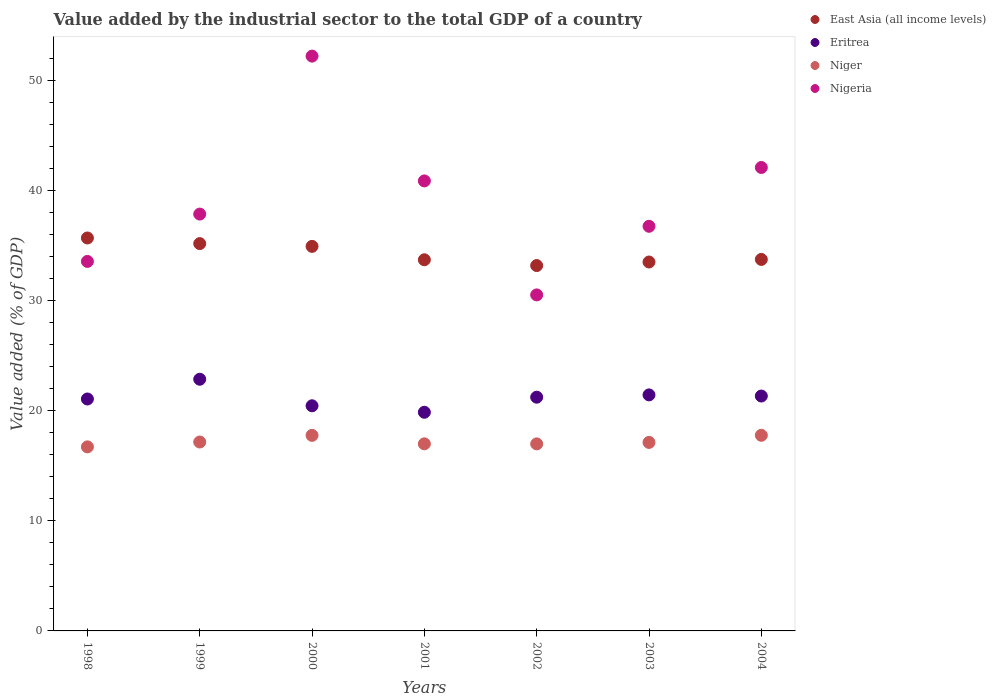How many different coloured dotlines are there?
Offer a terse response. 4. Is the number of dotlines equal to the number of legend labels?
Offer a terse response. Yes. What is the value added by the industrial sector to the total GDP in Niger in 1999?
Your answer should be very brief. 17.16. Across all years, what is the maximum value added by the industrial sector to the total GDP in Nigeria?
Keep it short and to the point. 52.21. Across all years, what is the minimum value added by the industrial sector to the total GDP in Nigeria?
Provide a succinct answer. 30.52. In which year was the value added by the industrial sector to the total GDP in Eritrea minimum?
Provide a short and direct response. 2001. What is the total value added by the industrial sector to the total GDP in East Asia (all income levels) in the graph?
Your answer should be compact. 239.93. What is the difference between the value added by the industrial sector to the total GDP in Eritrea in 1999 and that in 2000?
Offer a very short reply. 2.41. What is the difference between the value added by the industrial sector to the total GDP in East Asia (all income levels) in 1999 and the value added by the industrial sector to the total GDP in Eritrea in 2001?
Your response must be concise. 15.32. What is the average value added by the industrial sector to the total GDP in Eritrea per year?
Ensure brevity in your answer.  21.18. In the year 2003, what is the difference between the value added by the industrial sector to the total GDP in Eritrea and value added by the industrial sector to the total GDP in Nigeria?
Your answer should be very brief. -15.31. What is the ratio of the value added by the industrial sector to the total GDP in Nigeria in 2000 to that in 2001?
Keep it short and to the point. 1.28. Is the difference between the value added by the industrial sector to the total GDP in Eritrea in 1999 and 2000 greater than the difference between the value added by the industrial sector to the total GDP in Nigeria in 1999 and 2000?
Offer a terse response. Yes. What is the difference between the highest and the second highest value added by the industrial sector to the total GDP in East Asia (all income levels)?
Keep it short and to the point. 0.51. What is the difference between the highest and the lowest value added by the industrial sector to the total GDP in Eritrea?
Provide a succinct answer. 3. In how many years, is the value added by the industrial sector to the total GDP in Nigeria greater than the average value added by the industrial sector to the total GDP in Nigeria taken over all years?
Give a very brief answer. 3. Is the value added by the industrial sector to the total GDP in East Asia (all income levels) strictly greater than the value added by the industrial sector to the total GDP in Niger over the years?
Make the answer very short. Yes. How many years are there in the graph?
Offer a very short reply. 7. Are the values on the major ticks of Y-axis written in scientific E-notation?
Provide a short and direct response. No. Where does the legend appear in the graph?
Provide a succinct answer. Top right. What is the title of the graph?
Provide a short and direct response. Value added by the industrial sector to the total GDP of a country. What is the label or title of the Y-axis?
Give a very brief answer. Value added (% of GDP). What is the Value added (% of GDP) in East Asia (all income levels) in 1998?
Your response must be concise. 35.69. What is the Value added (% of GDP) in Eritrea in 1998?
Offer a terse response. 21.06. What is the Value added (% of GDP) in Niger in 1998?
Keep it short and to the point. 16.72. What is the Value added (% of GDP) of Nigeria in 1998?
Give a very brief answer. 33.56. What is the Value added (% of GDP) of East Asia (all income levels) in 1999?
Your response must be concise. 35.18. What is the Value added (% of GDP) of Eritrea in 1999?
Offer a very short reply. 22.86. What is the Value added (% of GDP) of Niger in 1999?
Provide a succinct answer. 17.16. What is the Value added (% of GDP) in Nigeria in 1999?
Give a very brief answer. 37.86. What is the Value added (% of GDP) of East Asia (all income levels) in 2000?
Offer a terse response. 34.93. What is the Value added (% of GDP) in Eritrea in 2000?
Your response must be concise. 20.45. What is the Value added (% of GDP) in Niger in 2000?
Ensure brevity in your answer.  17.76. What is the Value added (% of GDP) of Nigeria in 2000?
Make the answer very short. 52.21. What is the Value added (% of GDP) of East Asia (all income levels) in 2001?
Provide a short and direct response. 33.71. What is the Value added (% of GDP) of Eritrea in 2001?
Provide a succinct answer. 19.86. What is the Value added (% of GDP) of Niger in 2001?
Provide a short and direct response. 16.99. What is the Value added (% of GDP) in Nigeria in 2001?
Provide a short and direct response. 40.87. What is the Value added (% of GDP) of East Asia (all income levels) in 2002?
Offer a very short reply. 33.18. What is the Value added (% of GDP) of Eritrea in 2002?
Provide a short and direct response. 21.23. What is the Value added (% of GDP) of Niger in 2002?
Make the answer very short. 16.99. What is the Value added (% of GDP) of Nigeria in 2002?
Offer a terse response. 30.52. What is the Value added (% of GDP) of East Asia (all income levels) in 2003?
Offer a very short reply. 33.51. What is the Value added (% of GDP) in Eritrea in 2003?
Offer a terse response. 21.44. What is the Value added (% of GDP) in Niger in 2003?
Provide a succinct answer. 17.12. What is the Value added (% of GDP) in Nigeria in 2003?
Your answer should be compact. 36.75. What is the Value added (% of GDP) of East Asia (all income levels) in 2004?
Your answer should be very brief. 33.74. What is the Value added (% of GDP) of Eritrea in 2004?
Keep it short and to the point. 21.33. What is the Value added (% of GDP) of Niger in 2004?
Your answer should be very brief. 17.77. What is the Value added (% of GDP) of Nigeria in 2004?
Keep it short and to the point. 42.09. Across all years, what is the maximum Value added (% of GDP) in East Asia (all income levels)?
Provide a short and direct response. 35.69. Across all years, what is the maximum Value added (% of GDP) in Eritrea?
Make the answer very short. 22.86. Across all years, what is the maximum Value added (% of GDP) in Niger?
Provide a succinct answer. 17.77. Across all years, what is the maximum Value added (% of GDP) in Nigeria?
Give a very brief answer. 52.21. Across all years, what is the minimum Value added (% of GDP) in East Asia (all income levels)?
Give a very brief answer. 33.18. Across all years, what is the minimum Value added (% of GDP) of Eritrea?
Offer a very short reply. 19.86. Across all years, what is the minimum Value added (% of GDP) in Niger?
Offer a terse response. 16.72. Across all years, what is the minimum Value added (% of GDP) in Nigeria?
Give a very brief answer. 30.52. What is the total Value added (% of GDP) of East Asia (all income levels) in the graph?
Offer a very short reply. 239.93. What is the total Value added (% of GDP) in Eritrea in the graph?
Provide a short and direct response. 148.23. What is the total Value added (% of GDP) in Niger in the graph?
Your answer should be compact. 120.5. What is the total Value added (% of GDP) in Nigeria in the graph?
Your answer should be very brief. 273.85. What is the difference between the Value added (% of GDP) of East Asia (all income levels) in 1998 and that in 1999?
Make the answer very short. 0.51. What is the difference between the Value added (% of GDP) of Eritrea in 1998 and that in 1999?
Provide a short and direct response. -1.79. What is the difference between the Value added (% of GDP) in Niger in 1998 and that in 1999?
Keep it short and to the point. -0.44. What is the difference between the Value added (% of GDP) of Nigeria in 1998 and that in 1999?
Your answer should be very brief. -4.3. What is the difference between the Value added (% of GDP) of East Asia (all income levels) in 1998 and that in 2000?
Offer a terse response. 0.76. What is the difference between the Value added (% of GDP) of Eritrea in 1998 and that in 2000?
Ensure brevity in your answer.  0.62. What is the difference between the Value added (% of GDP) in Niger in 1998 and that in 2000?
Offer a very short reply. -1.04. What is the difference between the Value added (% of GDP) in Nigeria in 1998 and that in 2000?
Ensure brevity in your answer.  -18.65. What is the difference between the Value added (% of GDP) of East Asia (all income levels) in 1998 and that in 2001?
Your answer should be compact. 1.98. What is the difference between the Value added (% of GDP) of Eritrea in 1998 and that in 2001?
Give a very brief answer. 1.2. What is the difference between the Value added (% of GDP) in Niger in 1998 and that in 2001?
Provide a succinct answer. -0.28. What is the difference between the Value added (% of GDP) of Nigeria in 1998 and that in 2001?
Your response must be concise. -7.31. What is the difference between the Value added (% of GDP) of East Asia (all income levels) in 1998 and that in 2002?
Keep it short and to the point. 2.51. What is the difference between the Value added (% of GDP) of Eritrea in 1998 and that in 2002?
Provide a short and direct response. -0.16. What is the difference between the Value added (% of GDP) of Niger in 1998 and that in 2002?
Your response must be concise. -0.27. What is the difference between the Value added (% of GDP) in Nigeria in 1998 and that in 2002?
Offer a very short reply. 3.04. What is the difference between the Value added (% of GDP) in East Asia (all income levels) in 1998 and that in 2003?
Ensure brevity in your answer.  2.18. What is the difference between the Value added (% of GDP) of Eritrea in 1998 and that in 2003?
Your answer should be very brief. -0.37. What is the difference between the Value added (% of GDP) of Niger in 1998 and that in 2003?
Keep it short and to the point. -0.41. What is the difference between the Value added (% of GDP) of Nigeria in 1998 and that in 2003?
Keep it short and to the point. -3.19. What is the difference between the Value added (% of GDP) of East Asia (all income levels) in 1998 and that in 2004?
Your answer should be very brief. 1.95. What is the difference between the Value added (% of GDP) of Eritrea in 1998 and that in 2004?
Your response must be concise. -0.27. What is the difference between the Value added (% of GDP) of Niger in 1998 and that in 2004?
Offer a very short reply. -1.05. What is the difference between the Value added (% of GDP) in Nigeria in 1998 and that in 2004?
Your answer should be very brief. -8.53. What is the difference between the Value added (% of GDP) in East Asia (all income levels) in 1999 and that in 2000?
Provide a short and direct response. 0.25. What is the difference between the Value added (% of GDP) of Eritrea in 1999 and that in 2000?
Give a very brief answer. 2.41. What is the difference between the Value added (% of GDP) of Niger in 1999 and that in 2000?
Your answer should be compact. -0.6. What is the difference between the Value added (% of GDP) of Nigeria in 1999 and that in 2000?
Offer a terse response. -14.35. What is the difference between the Value added (% of GDP) in East Asia (all income levels) in 1999 and that in 2001?
Provide a short and direct response. 1.47. What is the difference between the Value added (% of GDP) of Eritrea in 1999 and that in 2001?
Your answer should be compact. 3. What is the difference between the Value added (% of GDP) in Niger in 1999 and that in 2001?
Ensure brevity in your answer.  0.17. What is the difference between the Value added (% of GDP) in Nigeria in 1999 and that in 2001?
Your response must be concise. -3.01. What is the difference between the Value added (% of GDP) in East Asia (all income levels) in 1999 and that in 2002?
Keep it short and to the point. 1.99. What is the difference between the Value added (% of GDP) of Eritrea in 1999 and that in 2002?
Make the answer very short. 1.63. What is the difference between the Value added (% of GDP) in Niger in 1999 and that in 2002?
Make the answer very short. 0.17. What is the difference between the Value added (% of GDP) of Nigeria in 1999 and that in 2002?
Offer a terse response. 7.34. What is the difference between the Value added (% of GDP) of East Asia (all income levels) in 1999 and that in 2003?
Ensure brevity in your answer.  1.67. What is the difference between the Value added (% of GDP) in Eritrea in 1999 and that in 2003?
Your response must be concise. 1.42. What is the difference between the Value added (% of GDP) of Niger in 1999 and that in 2003?
Offer a very short reply. 0.04. What is the difference between the Value added (% of GDP) in Nigeria in 1999 and that in 2003?
Provide a short and direct response. 1.11. What is the difference between the Value added (% of GDP) in East Asia (all income levels) in 1999 and that in 2004?
Ensure brevity in your answer.  1.44. What is the difference between the Value added (% of GDP) in Eritrea in 1999 and that in 2004?
Offer a very short reply. 1.53. What is the difference between the Value added (% of GDP) in Niger in 1999 and that in 2004?
Provide a succinct answer. -0.61. What is the difference between the Value added (% of GDP) of Nigeria in 1999 and that in 2004?
Offer a very short reply. -4.23. What is the difference between the Value added (% of GDP) in East Asia (all income levels) in 2000 and that in 2001?
Your answer should be compact. 1.22. What is the difference between the Value added (% of GDP) of Eritrea in 2000 and that in 2001?
Your answer should be very brief. 0.59. What is the difference between the Value added (% of GDP) in Niger in 2000 and that in 2001?
Your answer should be compact. 0.77. What is the difference between the Value added (% of GDP) of Nigeria in 2000 and that in 2001?
Your response must be concise. 11.33. What is the difference between the Value added (% of GDP) in East Asia (all income levels) in 2000 and that in 2002?
Offer a very short reply. 1.74. What is the difference between the Value added (% of GDP) of Eritrea in 2000 and that in 2002?
Your response must be concise. -0.78. What is the difference between the Value added (% of GDP) of Niger in 2000 and that in 2002?
Make the answer very short. 0.77. What is the difference between the Value added (% of GDP) of Nigeria in 2000 and that in 2002?
Ensure brevity in your answer.  21.69. What is the difference between the Value added (% of GDP) of East Asia (all income levels) in 2000 and that in 2003?
Provide a short and direct response. 1.42. What is the difference between the Value added (% of GDP) of Eritrea in 2000 and that in 2003?
Provide a short and direct response. -0.99. What is the difference between the Value added (% of GDP) in Niger in 2000 and that in 2003?
Provide a succinct answer. 0.64. What is the difference between the Value added (% of GDP) of Nigeria in 2000 and that in 2003?
Your answer should be very brief. 15.46. What is the difference between the Value added (% of GDP) in East Asia (all income levels) in 2000 and that in 2004?
Offer a very short reply. 1.19. What is the difference between the Value added (% of GDP) of Eritrea in 2000 and that in 2004?
Keep it short and to the point. -0.89. What is the difference between the Value added (% of GDP) in Niger in 2000 and that in 2004?
Provide a succinct answer. -0.01. What is the difference between the Value added (% of GDP) in Nigeria in 2000 and that in 2004?
Offer a very short reply. 10.11. What is the difference between the Value added (% of GDP) in East Asia (all income levels) in 2001 and that in 2002?
Provide a succinct answer. 0.53. What is the difference between the Value added (% of GDP) of Eritrea in 2001 and that in 2002?
Your answer should be compact. -1.37. What is the difference between the Value added (% of GDP) in Niger in 2001 and that in 2002?
Your answer should be very brief. 0. What is the difference between the Value added (% of GDP) of Nigeria in 2001 and that in 2002?
Provide a succinct answer. 10.35. What is the difference between the Value added (% of GDP) of East Asia (all income levels) in 2001 and that in 2003?
Ensure brevity in your answer.  0.2. What is the difference between the Value added (% of GDP) in Eritrea in 2001 and that in 2003?
Give a very brief answer. -1.58. What is the difference between the Value added (% of GDP) in Niger in 2001 and that in 2003?
Provide a short and direct response. -0.13. What is the difference between the Value added (% of GDP) of Nigeria in 2001 and that in 2003?
Provide a short and direct response. 4.12. What is the difference between the Value added (% of GDP) in East Asia (all income levels) in 2001 and that in 2004?
Provide a short and direct response. -0.03. What is the difference between the Value added (% of GDP) of Eritrea in 2001 and that in 2004?
Your answer should be very brief. -1.47. What is the difference between the Value added (% of GDP) of Niger in 2001 and that in 2004?
Your response must be concise. -0.77. What is the difference between the Value added (% of GDP) in Nigeria in 2001 and that in 2004?
Ensure brevity in your answer.  -1.22. What is the difference between the Value added (% of GDP) of East Asia (all income levels) in 2002 and that in 2003?
Your response must be concise. -0.32. What is the difference between the Value added (% of GDP) of Eritrea in 2002 and that in 2003?
Your answer should be compact. -0.21. What is the difference between the Value added (% of GDP) of Niger in 2002 and that in 2003?
Your answer should be very brief. -0.13. What is the difference between the Value added (% of GDP) of Nigeria in 2002 and that in 2003?
Give a very brief answer. -6.23. What is the difference between the Value added (% of GDP) of East Asia (all income levels) in 2002 and that in 2004?
Ensure brevity in your answer.  -0.56. What is the difference between the Value added (% of GDP) in Eritrea in 2002 and that in 2004?
Offer a terse response. -0.1. What is the difference between the Value added (% of GDP) of Niger in 2002 and that in 2004?
Give a very brief answer. -0.78. What is the difference between the Value added (% of GDP) of Nigeria in 2002 and that in 2004?
Ensure brevity in your answer.  -11.57. What is the difference between the Value added (% of GDP) in East Asia (all income levels) in 2003 and that in 2004?
Provide a succinct answer. -0.23. What is the difference between the Value added (% of GDP) of Eritrea in 2003 and that in 2004?
Your answer should be very brief. 0.1. What is the difference between the Value added (% of GDP) of Niger in 2003 and that in 2004?
Your answer should be compact. -0.64. What is the difference between the Value added (% of GDP) in Nigeria in 2003 and that in 2004?
Your answer should be very brief. -5.34. What is the difference between the Value added (% of GDP) in East Asia (all income levels) in 1998 and the Value added (% of GDP) in Eritrea in 1999?
Offer a very short reply. 12.83. What is the difference between the Value added (% of GDP) in East Asia (all income levels) in 1998 and the Value added (% of GDP) in Niger in 1999?
Provide a short and direct response. 18.53. What is the difference between the Value added (% of GDP) in East Asia (all income levels) in 1998 and the Value added (% of GDP) in Nigeria in 1999?
Your answer should be very brief. -2.17. What is the difference between the Value added (% of GDP) in Eritrea in 1998 and the Value added (% of GDP) in Niger in 1999?
Make the answer very short. 3.91. What is the difference between the Value added (% of GDP) of Eritrea in 1998 and the Value added (% of GDP) of Nigeria in 1999?
Your answer should be compact. -16.79. What is the difference between the Value added (% of GDP) of Niger in 1998 and the Value added (% of GDP) of Nigeria in 1999?
Your answer should be very brief. -21.14. What is the difference between the Value added (% of GDP) in East Asia (all income levels) in 1998 and the Value added (% of GDP) in Eritrea in 2000?
Offer a very short reply. 15.24. What is the difference between the Value added (% of GDP) of East Asia (all income levels) in 1998 and the Value added (% of GDP) of Niger in 2000?
Give a very brief answer. 17.93. What is the difference between the Value added (% of GDP) of East Asia (all income levels) in 1998 and the Value added (% of GDP) of Nigeria in 2000?
Ensure brevity in your answer.  -16.52. What is the difference between the Value added (% of GDP) in Eritrea in 1998 and the Value added (% of GDP) in Niger in 2000?
Offer a very short reply. 3.3. What is the difference between the Value added (% of GDP) in Eritrea in 1998 and the Value added (% of GDP) in Nigeria in 2000?
Your response must be concise. -31.14. What is the difference between the Value added (% of GDP) of Niger in 1998 and the Value added (% of GDP) of Nigeria in 2000?
Keep it short and to the point. -35.49. What is the difference between the Value added (% of GDP) of East Asia (all income levels) in 1998 and the Value added (% of GDP) of Eritrea in 2001?
Offer a very short reply. 15.83. What is the difference between the Value added (% of GDP) of East Asia (all income levels) in 1998 and the Value added (% of GDP) of Niger in 2001?
Offer a terse response. 18.7. What is the difference between the Value added (% of GDP) of East Asia (all income levels) in 1998 and the Value added (% of GDP) of Nigeria in 2001?
Offer a very short reply. -5.18. What is the difference between the Value added (% of GDP) of Eritrea in 1998 and the Value added (% of GDP) of Niger in 2001?
Provide a short and direct response. 4.07. What is the difference between the Value added (% of GDP) of Eritrea in 1998 and the Value added (% of GDP) of Nigeria in 2001?
Offer a terse response. -19.81. What is the difference between the Value added (% of GDP) of Niger in 1998 and the Value added (% of GDP) of Nigeria in 2001?
Offer a terse response. -24.16. What is the difference between the Value added (% of GDP) in East Asia (all income levels) in 1998 and the Value added (% of GDP) in Eritrea in 2002?
Make the answer very short. 14.46. What is the difference between the Value added (% of GDP) in East Asia (all income levels) in 1998 and the Value added (% of GDP) in Niger in 2002?
Your response must be concise. 18.7. What is the difference between the Value added (% of GDP) of East Asia (all income levels) in 1998 and the Value added (% of GDP) of Nigeria in 2002?
Offer a very short reply. 5.17. What is the difference between the Value added (% of GDP) of Eritrea in 1998 and the Value added (% of GDP) of Niger in 2002?
Ensure brevity in your answer.  4.08. What is the difference between the Value added (% of GDP) of Eritrea in 1998 and the Value added (% of GDP) of Nigeria in 2002?
Your response must be concise. -9.45. What is the difference between the Value added (% of GDP) in Niger in 1998 and the Value added (% of GDP) in Nigeria in 2002?
Give a very brief answer. -13.8. What is the difference between the Value added (% of GDP) in East Asia (all income levels) in 1998 and the Value added (% of GDP) in Eritrea in 2003?
Your answer should be very brief. 14.25. What is the difference between the Value added (% of GDP) in East Asia (all income levels) in 1998 and the Value added (% of GDP) in Niger in 2003?
Your answer should be compact. 18.57. What is the difference between the Value added (% of GDP) of East Asia (all income levels) in 1998 and the Value added (% of GDP) of Nigeria in 2003?
Provide a succinct answer. -1.06. What is the difference between the Value added (% of GDP) in Eritrea in 1998 and the Value added (% of GDP) in Niger in 2003?
Ensure brevity in your answer.  3.94. What is the difference between the Value added (% of GDP) of Eritrea in 1998 and the Value added (% of GDP) of Nigeria in 2003?
Keep it short and to the point. -15.69. What is the difference between the Value added (% of GDP) of Niger in 1998 and the Value added (% of GDP) of Nigeria in 2003?
Keep it short and to the point. -20.03. What is the difference between the Value added (% of GDP) in East Asia (all income levels) in 1998 and the Value added (% of GDP) in Eritrea in 2004?
Offer a terse response. 14.36. What is the difference between the Value added (% of GDP) in East Asia (all income levels) in 1998 and the Value added (% of GDP) in Niger in 2004?
Provide a short and direct response. 17.92. What is the difference between the Value added (% of GDP) of East Asia (all income levels) in 1998 and the Value added (% of GDP) of Nigeria in 2004?
Offer a terse response. -6.4. What is the difference between the Value added (% of GDP) of Eritrea in 1998 and the Value added (% of GDP) of Niger in 2004?
Make the answer very short. 3.3. What is the difference between the Value added (% of GDP) of Eritrea in 1998 and the Value added (% of GDP) of Nigeria in 2004?
Give a very brief answer. -21.03. What is the difference between the Value added (% of GDP) in Niger in 1998 and the Value added (% of GDP) in Nigeria in 2004?
Provide a short and direct response. -25.37. What is the difference between the Value added (% of GDP) of East Asia (all income levels) in 1999 and the Value added (% of GDP) of Eritrea in 2000?
Keep it short and to the point. 14.73. What is the difference between the Value added (% of GDP) in East Asia (all income levels) in 1999 and the Value added (% of GDP) in Niger in 2000?
Provide a short and direct response. 17.42. What is the difference between the Value added (% of GDP) in East Asia (all income levels) in 1999 and the Value added (% of GDP) in Nigeria in 2000?
Your answer should be compact. -17.03. What is the difference between the Value added (% of GDP) of Eritrea in 1999 and the Value added (% of GDP) of Niger in 2000?
Your response must be concise. 5.1. What is the difference between the Value added (% of GDP) in Eritrea in 1999 and the Value added (% of GDP) in Nigeria in 2000?
Provide a short and direct response. -29.35. What is the difference between the Value added (% of GDP) of Niger in 1999 and the Value added (% of GDP) of Nigeria in 2000?
Offer a terse response. -35.05. What is the difference between the Value added (% of GDP) in East Asia (all income levels) in 1999 and the Value added (% of GDP) in Eritrea in 2001?
Provide a short and direct response. 15.32. What is the difference between the Value added (% of GDP) in East Asia (all income levels) in 1999 and the Value added (% of GDP) in Niger in 2001?
Your answer should be very brief. 18.19. What is the difference between the Value added (% of GDP) in East Asia (all income levels) in 1999 and the Value added (% of GDP) in Nigeria in 2001?
Provide a succinct answer. -5.69. What is the difference between the Value added (% of GDP) of Eritrea in 1999 and the Value added (% of GDP) of Niger in 2001?
Offer a terse response. 5.87. What is the difference between the Value added (% of GDP) in Eritrea in 1999 and the Value added (% of GDP) in Nigeria in 2001?
Give a very brief answer. -18.01. What is the difference between the Value added (% of GDP) in Niger in 1999 and the Value added (% of GDP) in Nigeria in 2001?
Make the answer very short. -23.71. What is the difference between the Value added (% of GDP) in East Asia (all income levels) in 1999 and the Value added (% of GDP) in Eritrea in 2002?
Keep it short and to the point. 13.95. What is the difference between the Value added (% of GDP) in East Asia (all income levels) in 1999 and the Value added (% of GDP) in Niger in 2002?
Keep it short and to the point. 18.19. What is the difference between the Value added (% of GDP) of East Asia (all income levels) in 1999 and the Value added (% of GDP) of Nigeria in 2002?
Your answer should be compact. 4.66. What is the difference between the Value added (% of GDP) in Eritrea in 1999 and the Value added (% of GDP) in Niger in 2002?
Offer a terse response. 5.87. What is the difference between the Value added (% of GDP) in Eritrea in 1999 and the Value added (% of GDP) in Nigeria in 2002?
Your answer should be compact. -7.66. What is the difference between the Value added (% of GDP) in Niger in 1999 and the Value added (% of GDP) in Nigeria in 2002?
Offer a terse response. -13.36. What is the difference between the Value added (% of GDP) in East Asia (all income levels) in 1999 and the Value added (% of GDP) in Eritrea in 2003?
Offer a terse response. 13.74. What is the difference between the Value added (% of GDP) of East Asia (all income levels) in 1999 and the Value added (% of GDP) of Niger in 2003?
Keep it short and to the point. 18.06. What is the difference between the Value added (% of GDP) in East Asia (all income levels) in 1999 and the Value added (% of GDP) in Nigeria in 2003?
Your answer should be compact. -1.57. What is the difference between the Value added (% of GDP) of Eritrea in 1999 and the Value added (% of GDP) of Niger in 2003?
Your response must be concise. 5.74. What is the difference between the Value added (% of GDP) in Eritrea in 1999 and the Value added (% of GDP) in Nigeria in 2003?
Provide a short and direct response. -13.89. What is the difference between the Value added (% of GDP) of Niger in 1999 and the Value added (% of GDP) of Nigeria in 2003?
Keep it short and to the point. -19.59. What is the difference between the Value added (% of GDP) in East Asia (all income levels) in 1999 and the Value added (% of GDP) in Eritrea in 2004?
Provide a short and direct response. 13.84. What is the difference between the Value added (% of GDP) in East Asia (all income levels) in 1999 and the Value added (% of GDP) in Niger in 2004?
Offer a very short reply. 17.41. What is the difference between the Value added (% of GDP) of East Asia (all income levels) in 1999 and the Value added (% of GDP) of Nigeria in 2004?
Ensure brevity in your answer.  -6.91. What is the difference between the Value added (% of GDP) of Eritrea in 1999 and the Value added (% of GDP) of Niger in 2004?
Your response must be concise. 5.09. What is the difference between the Value added (% of GDP) of Eritrea in 1999 and the Value added (% of GDP) of Nigeria in 2004?
Offer a terse response. -19.23. What is the difference between the Value added (% of GDP) of Niger in 1999 and the Value added (% of GDP) of Nigeria in 2004?
Keep it short and to the point. -24.93. What is the difference between the Value added (% of GDP) in East Asia (all income levels) in 2000 and the Value added (% of GDP) in Eritrea in 2001?
Your answer should be compact. 15.07. What is the difference between the Value added (% of GDP) in East Asia (all income levels) in 2000 and the Value added (% of GDP) in Niger in 2001?
Keep it short and to the point. 17.93. What is the difference between the Value added (% of GDP) of East Asia (all income levels) in 2000 and the Value added (% of GDP) of Nigeria in 2001?
Your answer should be very brief. -5.95. What is the difference between the Value added (% of GDP) in Eritrea in 2000 and the Value added (% of GDP) in Niger in 2001?
Your response must be concise. 3.46. What is the difference between the Value added (% of GDP) of Eritrea in 2000 and the Value added (% of GDP) of Nigeria in 2001?
Offer a very short reply. -20.42. What is the difference between the Value added (% of GDP) in Niger in 2000 and the Value added (% of GDP) in Nigeria in 2001?
Your answer should be compact. -23.11. What is the difference between the Value added (% of GDP) of East Asia (all income levels) in 2000 and the Value added (% of GDP) of Eritrea in 2002?
Your answer should be compact. 13.7. What is the difference between the Value added (% of GDP) of East Asia (all income levels) in 2000 and the Value added (% of GDP) of Niger in 2002?
Your answer should be compact. 17.94. What is the difference between the Value added (% of GDP) of East Asia (all income levels) in 2000 and the Value added (% of GDP) of Nigeria in 2002?
Your answer should be compact. 4.41. What is the difference between the Value added (% of GDP) in Eritrea in 2000 and the Value added (% of GDP) in Niger in 2002?
Make the answer very short. 3.46. What is the difference between the Value added (% of GDP) in Eritrea in 2000 and the Value added (% of GDP) in Nigeria in 2002?
Offer a very short reply. -10.07. What is the difference between the Value added (% of GDP) of Niger in 2000 and the Value added (% of GDP) of Nigeria in 2002?
Offer a terse response. -12.76. What is the difference between the Value added (% of GDP) of East Asia (all income levels) in 2000 and the Value added (% of GDP) of Eritrea in 2003?
Give a very brief answer. 13.49. What is the difference between the Value added (% of GDP) in East Asia (all income levels) in 2000 and the Value added (% of GDP) in Niger in 2003?
Keep it short and to the point. 17.81. What is the difference between the Value added (% of GDP) in East Asia (all income levels) in 2000 and the Value added (% of GDP) in Nigeria in 2003?
Provide a succinct answer. -1.82. What is the difference between the Value added (% of GDP) in Eritrea in 2000 and the Value added (% of GDP) in Niger in 2003?
Ensure brevity in your answer.  3.33. What is the difference between the Value added (% of GDP) in Eritrea in 2000 and the Value added (% of GDP) in Nigeria in 2003?
Ensure brevity in your answer.  -16.3. What is the difference between the Value added (% of GDP) of Niger in 2000 and the Value added (% of GDP) of Nigeria in 2003?
Your answer should be compact. -18.99. What is the difference between the Value added (% of GDP) in East Asia (all income levels) in 2000 and the Value added (% of GDP) in Eritrea in 2004?
Give a very brief answer. 13.59. What is the difference between the Value added (% of GDP) in East Asia (all income levels) in 2000 and the Value added (% of GDP) in Niger in 2004?
Offer a terse response. 17.16. What is the difference between the Value added (% of GDP) in East Asia (all income levels) in 2000 and the Value added (% of GDP) in Nigeria in 2004?
Make the answer very short. -7.16. What is the difference between the Value added (% of GDP) in Eritrea in 2000 and the Value added (% of GDP) in Niger in 2004?
Provide a succinct answer. 2.68. What is the difference between the Value added (% of GDP) of Eritrea in 2000 and the Value added (% of GDP) of Nigeria in 2004?
Offer a very short reply. -21.64. What is the difference between the Value added (% of GDP) in Niger in 2000 and the Value added (% of GDP) in Nigeria in 2004?
Your answer should be compact. -24.33. What is the difference between the Value added (% of GDP) of East Asia (all income levels) in 2001 and the Value added (% of GDP) of Eritrea in 2002?
Offer a very short reply. 12.48. What is the difference between the Value added (% of GDP) of East Asia (all income levels) in 2001 and the Value added (% of GDP) of Niger in 2002?
Give a very brief answer. 16.72. What is the difference between the Value added (% of GDP) of East Asia (all income levels) in 2001 and the Value added (% of GDP) of Nigeria in 2002?
Your response must be concise. 3.19. What is the difference between the Value added (% of GDP) of Eritrea in 2001 and the Value added (% of GDP) of Niger in 2002?
Make the answer very short. 2.87. What is the difference between the Value added (% of GDP) of Eritrea in 2001 and the Value added (% of GDP) of Nigeria in 2002?
Your answer should be very brief. -10.66. What is the difference between the Value added (% of GDP) in Niger in 2001 and the Value added (% of GDP) in Nigeria in 2002?
Your response must be concise. -13.53. What is the difference between the Value added (% of GDP) in East Asia (all income levels) in 2001 and the Value added (% of GDP) in Eritrea in 2003?
Your answer should be very brief. 12.27. What is the difference between the Value added (% of GDP) of East Asia (all income levels) in 2001 and the Value added (% of GDP) of Niger in 2003?
Make the answer very short. 16.59. What is the difference between the Value added (% of GDP) of East Asia (all income levels) in 2001 and the Value added (% of GDP) of Nigeria in 2003?
Your answer should be compact. -3.04. What is the difference between the Value added (% of GDP) in Eritrea in 2001 and the Value added (% of GDP) in Niger in 2003?
Your answer should be very brief. 2.74. What is the difference between the Value added (% of GDP) in Eritrea in 2001 and the Value added (% of GDP) in Nigeria in 2003?
Make the answer very short. -16.89. What is the difference between the Value added (% of GDP) in Niger in 2001 and the Value added (% of GDP) in Nigeria in 2003?
Make the answer very short. -19.76. What is the difference between the Value added (% of GDP) in East Asia (all income levels) in 2001 and the Value added (% of GDP) in Eritrea in 2004?
Your answer should be very brief. 12.38. What is the difference between the Value added (% of GDP) of East Asia (all income levels) in 2001 and the Value added (% of GDP) of Niger in 2004?
Your answer should be very brief. 15.94. What is the difference between the Value added (% of GDP) in East Asia (all income levels) in 2001 and the Value added (% of GDP) in Nigeria in 2004?
Give a very brief answer. -8.38. What is the difference between the Value added (% of GDP) in Eritrea in 2001 and the Value added (% of GDP) in Niger in 2004?
Provide a succinct answer. 2.09. What is the difference between the Value added (% of GDP) of Eritrea in 2001 and the Value added (% of GDP) of Nigeria in 2004?
Provide a short and direct response. -22.23. What is the difference between the Value added (% of GDP) in Niger in 2001 and the Value added (% of GDP) in Nigeria in 2004?
Your answer should be very brief. -25.1. What is the difference between the Value added (% of GDP) of East Asia (all income levels) in 2002 and the Value added (% of GDP) of Eritrea in 2003?
Keep it short and to the point. 11.75. What is the difference between the Value added (% of GDP) of East Asia (all income levels) in 2002 and the Value added (% of GDP) of Niger in 2003?
Offer a terse response. 16.06. What is the difference between the Value added (% of GDP) of East Asia (all income levels) in 2002 and the Value added (% of GDP) of Nigeria in 2003?
Provide a short and direct response. -3.57. What is the difference between the Value added (% of GDP) of Eritrea in 2002 and the Value added (% of GDP) of Niger in 2003?
Offer a very short reply. 4.11. What is the difference between the Value added (% of GDP) of Eritrea in 2002 and the Value added (% of GDP) of Nigeria in 2003?
Your response must be concise. -15.52. What is the difference between the Value added (% of GDP) in Niger in 2002 and the Value added (% of GDP) in Nigeria in 2003?
Provide a short and direct response. -19.76. What is the difference between the Value added (% of GDP) of East Asia (all income levels) in 2002 and the Value added (% of GDP) of Eritrea in 2004?
Provide a succinct answer. 11.85. What is the difference between the Value added (% of GDP) of East Asia (all income levels) in 2002 and the Value added (% of GDP) of Niger in 2004?
Give a very brief answer. 15.42. What is the difference between the Value added (% of GDP) of East Asia (all income levels) in 2002 and the Value added (% of GDP) of Nigeria in 2004?
Provide a succinct answer. -8.91. What is the difference between the Value added (% of GDP) in Eritrea in 2002 and the Value added (% of GDP) in Niger in 2004?
Make the answer very short. 3.46. What is the difference between the Value added (% of GDP) in Eritrea in 2002 and the Value added (% of GDP) in Nigeria in 2004?
Your answer should be compact. -20.86. What is the difference between the Value added (% of GDP) of Niger in 2002 and the Value added (% of GDP) of Nigeria in 2004?
Offer a very short reply. -25.1. What is the difference between the Value added (% of GDP) of East Asia (all income levels) in 2003 and the Value added (% of GDP) of Eritrea in 2004?
Your answer should be compact. 12.17. What is the difference between the Value added (% of GDP) of East Asia (all income levels) in 2003 and the Value added (% of GDP) of Niger in 2004?
Your answer should be very brief. 15.74. What is the difference between the Value added (% of GDP) in East Asia (all income levels) in 2003 and the Value added (% of GDP) in Nigeria in 2004?
Give a very brief answer. -8.58. What is the difference between the Value added (% of GDP) of Eritrea in 2003 and the Value added (% of GDP) of Niger in 2004?
Make the answer very short. 3.67. What is the difference between the Value added (% of GDP) in Eritrea in 2003 and the Value added (% of GDP) in Nigeria in 2004?
Provide a short and direct response. -20.65. What is the difference between the Value added (% of GDP) of Niger in 2003 and the Value added (% of GDP) of Nigeria in 2004?
Offer a terse response. -24.97. What is the average Value added (% of GDP) of East Asia (all income levels) per year?
Make the answer very short. 34.28. What is the average Value added (% of GDP) of Eritrea per year?
Offer a terse response. 21.18. What is the average Value added (% of GDP) in Niger per year?
Offer a very short reply. 17.21. What is the average Value added (% of GDP) in Nigeria per year?
Provide a succinct answer. 39.12. In the year 1998, what is the difference between the Value added (% of GDP) in East Asia (all income levels) and Value added (% of GDP) in Eritrea?
Keep it short and to the point. 14.62. In the year 1998, what is the difference between the Value added (% of GDP) of East Asia (all income levels) and Value added (% of GDP) of Niger?
Give a very brief answer. 18.97. In the year 1998, what is the difference between the Value added (% of GDP) of East Asia (all income levels) and Value added (% of GDP) of Nigeria?
Keep it short and to the point. 2.13. In the year 1998, what is the difference between the Value added (% of GDP) of Eritrea and Value added (% of GDP) of Niger?
Your answer should be compact. 4.35. In the year 1998, what is the difference between the Value added (% of GDP) of Eritrea and Value added (% of GDP) of Nigeria?
Ensure brevity in your answer.  -12.5. In the year 1998, what is the difference between the Value added (% of GDP) of Niger and Value added (% of GDP) of Nigeria?
Give a very brief answer. -16.84. In the year 1999, what is the difference between the Value added (% of GDP) of East Asia (all income levels) and Value added (% of GDP) of Eritrea?
Offer a very short reply. 12.32. In the year 1999, what is the difference between the Value added (% of GDP) in East Asia (all income levels) and Value added (% of GDP) in Niger?
Keep it short and to the point. 18.02. In the year 1999, what is the difference between the Value added (% of GDP) in East Asia (all income levels) and Value added (% of GDP) in Nigeria?
Keep it short and to the point. -2.68. In the year 1999, what is the difference between the Value added (% of GDP) of Eritrea and Value added (% of GDP) of Niger?
Keep it short and to the point. 5.7. In the year 1999, what is the difference between the Value added (% of GDP) of Eritrea and Value added (% of GDP) of Nigeria?
Provide a succinct answer. -15. In the year 1999, what is the difference between the Value added (% of GDP) in Niger and Value added (% of GDP) in Nigeria?
Give a very brief answer. -20.7. In the year 2000, what is the difference between the Value added (% of GDP) of East Asia (all income levels) and Value added (% of GDP) of Eritrea?
Give a very brief answer. 14.48. In the year 2000, what is the difference between the Value added (% of GDP) in East Asia (all income levels) and Value added (% of GDP) in Niger?
Ensure brevity in your answer.  17.17. In the year 2000, what is the difference between the Value added (% of GDP) in East Asia (all income levels) and Value added (% of GDP) in Nigeria?
Give a very brief answer. -17.28. In the year 2000, what is the difference between the Value added (% of GDP) of Eritrea and Value added (% of GDP) of Niger?
Make the answer very short. 2.69. In the year 2000, what is the difference between the Value added (% of GDP) in Eritrea and Value added (% of GDP) in Nigeria?
Your answer should be compact. -31.76. In the year 2000, what is the difference between the Value added (% of GDP) of Niger and Value added (% of GDP) of Nigeria?
Your response must be concise. -34.45. In the year 2001, what is the difference between the Value added (% of GDP) of East Asia (all income levels) and Value added (% of GDP) of Eritrea?
Your response must be concise. 13.85. In the year 2001, what is the difference between the Value added (% of GDP) in East Asia (all income levels) and Value added (% of GDP) in Niger?
Offer a terse response. 16.72. In the year 2001, what is the difference between the Value added (% of GDP) of East Asia (all income levels) and Value added (% of GDP) of Nigeria?
Keep it short and to the point. -7.16. In the year 2001, what is the difference between the Value added (% of GDP) in Eritrea and Value added (% of GDP) in Niger?
Provide a short and direct response. 2.87. In the year 2001, what is the difference between the Value added (% of GDP) of Eritrea and Value added (% of GDP) of Nigeria?
Provide a short and direct response. -21.01. In the year 2001, what is the difference between the Value added (% of GDP) in Niger and Value added (% of GDP) in Nigeria?
Offer a terse response. -23.88. In the year 2002, what is the difference between the Value added (% of GDP) in East Asia (all income levels) and Value added (% of GDP) in Eritrea?
Provide a short and direct response. 11.95. In the year 2002, what is the difference between the Value added (% of GDP) in East Asia (all income levels) and Value added (% of GDP) in Niger?
Keep it short and to the point. 16.19. In the year 2002, what is the difference between the Value added (% of GDP) in East Asia (all income levels) and Value added (% of GDP) in Nigeria?
Offer a very short reply. 2.67. In the year 2002, what is the difference between the Value added (% of GDP) in Eritrea and Value added (% of GDP) in Niger?
Provide a succinct answer. 4.24. In the year 2002, what is the difference between the Value added (% of GDP) of Eritrea and Value added (% of GDP) of Nigeria?
Make the answer very short. -9.29. In the year 2002, what is the difference between the Value added (% of GDP) of Niger and Value added (% of GDP) of Nigeria?
Ensure brevity in your answer.  -13.53. In the year 2003, what is the difference between the Value added (% of GDP) in East Asia (all income levels) and Value added (% of GDP) in Eritrea?
Ensure brevity in your answer.  12.07. In the year 2003, what is the difference between the Value added (% of GDP) of East Asia (all income levels) and Value added (% of GDP) of Niger?
Provide a short and direct response. 16.38. In the year 2003, what is the difference between the Value added (% of GDP) in East Asia (all income levels) and Value added (% of GDP) in Nigeria?
Your response must be concise. -3.24. In the year 2003, what is the difference between the Value added (% of GDP) of Eritrea and Value added (% of GDP) of Niger?
Ensure brevity in your answer.  4.31. In the year 2003, what is the difference between the Value added (% of GDP) of Eritrea and Value added (% of GDP) of Nigeria?
Make the answer very short. -15.31. In the year 2003, what is the difference between the Value added (% of GDP) in Niger and Value added (% of GDP) in Nigeria?
Your response must be concise. -19.63. In the year 2004, what is the difference between the Value added (% of GDP) in East Asia (all income levels) and Value added (% of GDP) in Eritrea?
Make the answer very short. 12.41. In the year 2004, what is the difference between the Value added (% of GDP) in East Asia (all income levels) and Value added (% of GDP) in Niger?
Your answer should be very brief. 15.97. In the year 2004, what is the difference between the Value added (% of GDP) of East Asia (all income levels) and Value added (% of GDP) of Nigeria?
Offer a very short reply. -8.35. In the year 2004, what is the difference between the Value added (% of GDP) in Eritrea and Value added (% of GDP) in Niger?
Provide a succinct answer. 3.57. In the year 2004, what is the difference between the Value added (% of GDP) in Eritrea and Value added (% of GDP) in Nigeria?
Provide a short and direct response. -20.76. In the year 2004, what is the difference between the Value added (% of GDP) in Niger and Value added (% of GDP) in Nigeria?
Provide a short and direct response. -24.32. What is the ratio of the Value added (% of GDP) of East Asia (all income levels) in 1998 to that in 1999?
Keep it short and to the point. 1.01. What is the ratio of the Value added (% of GDP) of Eritrea in 1998 to that in 1999?
Offer a terse response. 0.92. What is the ratio of the Value added (% of GDP) in Niger in 1998 to that in 1999?
Make the answer very short. 0.97. What is the ratio of the Value added (% of GDP) in Nigeria in 1998 to that in 1999?
Offer a very short reply. 0.89. What is the ratio of the Value added (% of GDP) in East Asia (all income levels) in 1998 to that in 2000?
Make the answer very short. 1.02. What is the ratio of the Value added (% of GDP) of Eritrea in 1998 to that in 2000?
Your answer should be very brief. 1.03. What is the ratio of the Value added (% of GDP) in Niger in 1998 to that in 2000?
Provide a succinct answer. 0.94. What is the ratio of the Value added (% of GDP) of Nigeria in 1998 to that in 2000?
Your answer should be very brief. 0.64. What is the ratio of the Value added (% of GDP) in East Asia (all income levels) in 1998 to that in 2001?
Offer a very short reply. 1.06. What is the ratio of the Value added (% of GDP) in Eritrea in 1998 to that in 2001?
Offer a very short reply. 1.06. What is the ratio of the Value added (% of GDP) in Niger in 1998 to that in 2001?
Offer a very short reply. 0.98. What is the ratio of the Value added (% of GDP) in Nigeria in 1998 to that in 2001?
Keep it short and to the point. 0.82. What is the ratio of the Value added (% of GDP) of East Asia (all income levels) in 1998 to that in 2002?
Provide a succinct answer. 1.08. What is the ratio of the Value added (% of GDP) of Niger in 1998 to that in 2002?
Offer a terse response. 0.98. What is the ratio of the Value added (% of GDP) in Nigeria in 1998 to that in 2002?
Offer a terse response. 1.1. What is the ratio of the Value added (% of GDP) in East Asia (all income levels) in 1998 to that in 2003?
Offer a terse response. 1.07. What is the ratio of the Value added (% of GDP) of Eritrea in 1998 to that in 2003?
Your answer should be compact. 0.98. What is the ratio of the Value added (% of GDP) in Niger in 1998 to that in 2003?
Give a very brief answer. 0.98. What is the ratio of the Value added (% of GDP) of Nigeria in 1998 to that in 2003?
Offer a very short reply. 0.91. What is the ratio of the Value added (% of GDP) in East Asia (all income levels) in 1998 to that in 2004?
Your answer should be compact. 1.06. What is the ratio of the Value added (% of GDP) of Eritrea in 1998 to that in 2004?
Make the answer very short. 0.99. What is the ratio of the Value added (% of GDP) in Niger in 1998 to that in 2004?
Make the answer very short. 0.94. What is the ratio of the Value added (% of GDP) of Nigeria in 1998 to that in 2004?
Your answer should be very brief. 0.8. What is the ratio of the Value added (% of GDP) of Eritrea in 1999 to that in 2000?
Keep it short and to the point. 1.12. What is the ratio of the Value added (% of GDP) of Niger in 1999 to that in 2000?
Your response must be concise. 0.97. What is the ratio of the Value added (% of GDP) in Nigeria in 1999 to that in 2000?
Ensure brevity in your answer.  0.73. What is the ratio of the Value added (% of GDP) of East Asia (all income levels) in 1999 to that in 2001?
Offer a very short reply. 1.04. What is the ratio of the Value added (% of GDP) of Eritrea in 1999 to that in 2001?
Your answer should be compact. 1.15. What is the ratio of the Value added (% of GDP) in Niger in 1999 to that in 2001?
Offer a very short reply. 1.01. What is the ratio of the Value added (% of GDP) in Nigeria in 1999 to that in 2001?
Offer a terse response. 0.93. What is the ratio of the Value added (% of GDP) of East Asia (all income levels) in 1999 to that in 2002?
Offer a very short reply. 1.06. What is the ratio of the Value added (% of GDP) in Eritrea in 1999 to that in 2002?
Your answer should be very brief. 1.08. What is the ratio of the Value added (% of GDP) in Nigeria in 1999 to that in 2002?
Your answer should be very brief. 1.24. What is the ratio of the Value added (% of GDP) of East Asia (all income levels) in 1999 to that in 2003?
Keep it short and to the point. 1.05. What is the ratio of the Value added (% of GDP) in Eritrea in 1999 to that in 2003?
Offer a terse response. 1.07. What is the ratio of the Value added (% of GDP) of Nigeria in 1999 to that in 2003?
Provide a short and direct response. 1.03. What is the ratio of the Value added (% of GDP) in East Asia (all income levels) in 1999 to that in 2004?
Offer a terse response. 1.04. What is the ratio of the Value added (% of GDP) in Eritrea in 1999 to that in 2004?
Your answer should be very brief. 1.07. What is the ratio of the Value added (% of GDP) of Niger in 1999 to that in 2004?
Make the answer very short. 0.97. What is the ratio of the Value added (% of GDP) in Nigeria in 1999 to that in 2004?
Your answer should be compact. 0.9. What is the ratio of the Value added (% of GDP) in East Asia (all income levels) in 2000 to that in 2001?
Offer a very short reply. 1.04. What is the ratio of the Value added (% of GDP) of Eritrea in 2000 to that in 2001?
Keep it short and to the point. 1.03. What is the ratio of the Value added (% of GDP) in Niger in 2000 to that in 2001?
Provide a short and direct response. 1.05. What is the ratio of the Value added (% of GDP) in Nigeria in 2000 to that in 2001?
Your answer should be compact. 1.28. What is the ratio of the Value added (% of GDP) of East Asia (all income levels) in 2000 to that in 2002?
Make the answer very short. 1.05. What is the ratio of the Value added (% of GDP) of Eritrea in 2000 to that in 2002?
Your answer should be compact. 0.96. What is the ratio of the Value added (% of GDP) in Niger in 2000 to that in 2002?
Ensure brevity in your answer.  1.05. What is the ratio of the Value added (% of GDP) in Nigeria in 2000 to that in 2002?
Your answer should be compact. 1.71. What is the ratio of the Value added (% of GDP) in East Asia (all income levels) in 2000 to that in 2003?
Make the answer very short. 1.04. What is the ratio of the Value added (% of GDP) of Eritrea in 2000 to that in 2003?
Your answer should be very brief. 0.95. What is the ratio of the Value added (% of GDP) of Niger in 2000 to that in 2003?
Provide a short and direct response. 1.04. What is the ratio of the Value added (% of GDP) in Nigeria in 2000 to that in 2003?
Offer a very short reply. 1.42. What is the ratio of the Value added (% of GDP) of East Asia (all income levels) in 2000 to that in 2004?
Keep it short and to the point. 1.04. What is the ratio of the Value added (% of GDP) of Eritrea in 2000 to that in 2004?
Make the answer very short. 0.96. What is the ratio of the Value added (% of GDP) in Nigeria in 2000 to that in 2004?
Your answer should be very brief. 1.24. What is the ratio of the Value added (% of GDP) of East Asia (all income levels) in 2001 to that in 2002?
Your answer should be very brief. 1.02. What is the ratio of the Value added (% of GDP) of Eritrea in 2001 to that in 2002?
Keep it short and to the point. 0.94. What is the ratio of the Value added (% of GDP) of Nigeria in 2001 to that in 2002?
Give a very brief answer. 1.34. What is the ratio of the Value added (% of GDP) of Eritrea in 2001 to that in 2003?
Your response must be concise. 0.93. What is the ratio of the Value added (% of GDP) of Niger in 2001 to that in 2003?
Your response must be concise. 0.99. What is the ratio of the Value added (% of GDP) in Nigeria in 2001 to that in 2003?
Offer a terse response. 1.11. What is the ratio of the Value added (% of GDP) of East Asia (all income levels) in 2001 to that in 2004?
Provide a succinct answer. 1. What is the ratio of the Value added (% of GDP) of Eritrea in 2001 to that in 2004?
Provide a short and direct response. 0.93. What is the ratio of the Value added (% of GDP) of Niger in 2001 to that in 2004?
Ensure brevity in your answer.  0.96. What is the ratio of the Value added (% of GDP) in Nigeria in 2001 to that in 2004?
Give a very brief answer. 0.97. What is the ratio of the Value added (% of GDP) of East Asia (all income levels) in 2002 to that in 2003?
Give a very brief answer. 0.99. What is the ratio of the Value added (% of GDP) of Eritrea in 2002 to that in 2003?
Make the answer very short. 0.99. What is the ratio of the Value added (% of GDP) of Nigeria in 2002 to that in 2003?
Offer a very short reply. 0.83. What is the ratio of the Value added (% of GDP) of East Asia (all income levels) in 2002 to that in 2004?
Your answer should be compact. 0.98. What is the ratio of the Value added (% of GDP) of Eritrea in 2002 to that in 2004?
Provide a short and direct response. 1. What is the ratio of the Value added (% of GDP) of Niger in 2002 to that in 2004?
Your answer should be compact. 0.96. What is the ratio of the Value added (% of GDP) of Nigeria in 2002 to that in 2004?
Offer a terse response. 0.73. What is the ratio of the Value added (% of GDP) in East Asia (all income levels) in 2003 to that in 2004?
Offer a very short reply. 0.99. What is the ratio of the Value added (% of GDP) of Eritrea in 2003 to that in 2004?
Offer a very short reply. 1. What is the ratio of the Value added (% of GDP) of Niger in 2003 to that in 2004?
Provide a short and direct response. 0.96. What is the ratio of the Value added (% of GDP) of Nigeria in 2003 to that in 2004?
Your answer should be compact. 0.87. What is the difference between the highest and the second highest Value added (% of GDP) of East Asia (all income levels)?
Make the answer very short. 0.51. What is the difference between the highest and the second highest Value added (% of GDP) of Eritrea?
Provide a succinct answer. 1.42. What is the difference between the highest and the second highest Value added (% of GDP) of Niger?
Make the answer very short. 0.01. What is the difference between the highest and the second highest Value added (% of GDP) in Nigeria?
Offer a very short reply. 10.11. What is the difference between the highest and the lowest Value added (% of GDP) in East Asia (all income levels)?
Offer a terse response. 2.51. What is the difference between the highest and the lowest Value added (% of GDP) of Eritrea?
Your answer should be very brief. 3. What is the difference between the highest and the lowest Value added (% of GDP) in Niger?
Your answer should be compact. 1.05. What is the difference between the highest and the lowest Value added (% of GDP) in Nigeria?
Offer a terse response. 21.69. 